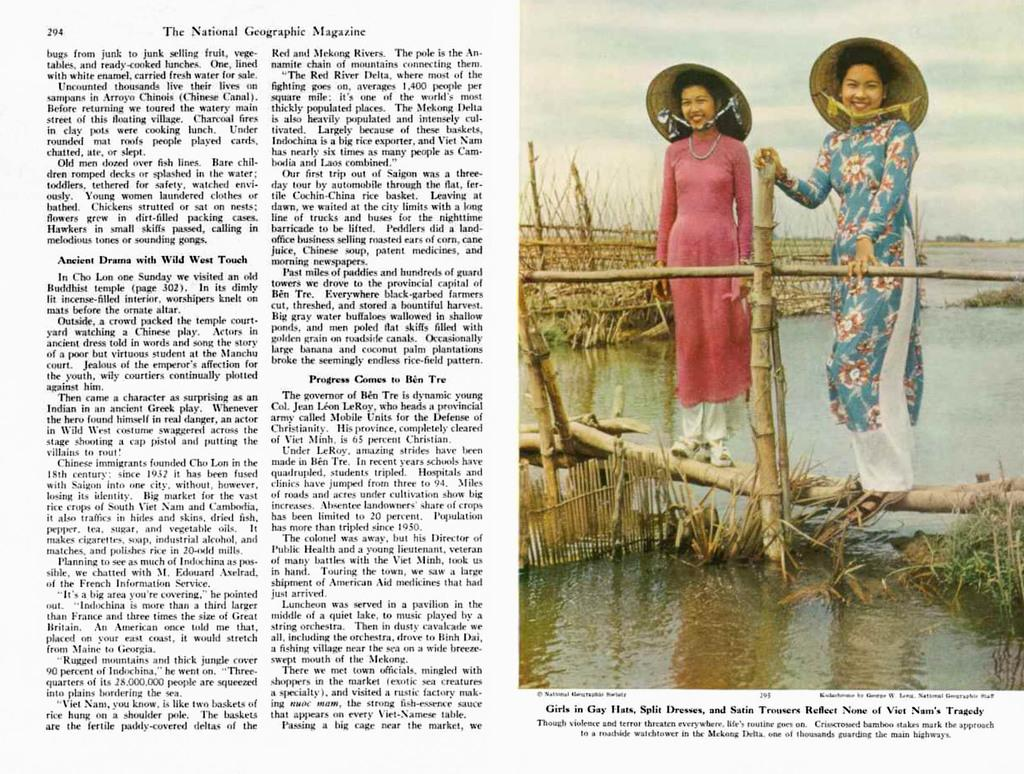What is the main subject of the image? The image contains an article. Can you describe the people in the image? There are two ladies standing on sticks in the image, and they are wearing hats. What can be seen at the bottom of the image? There is water visible at the bottom of the image. Where is the text located in the image? The text is on the left side of the image. What type of war is depicted in the image? There is no depiction of war in the image; it features an article, two ladies standing on sticks, and water at the bottom. How many trucks are visible in the image? There are no trucks present in the image. 